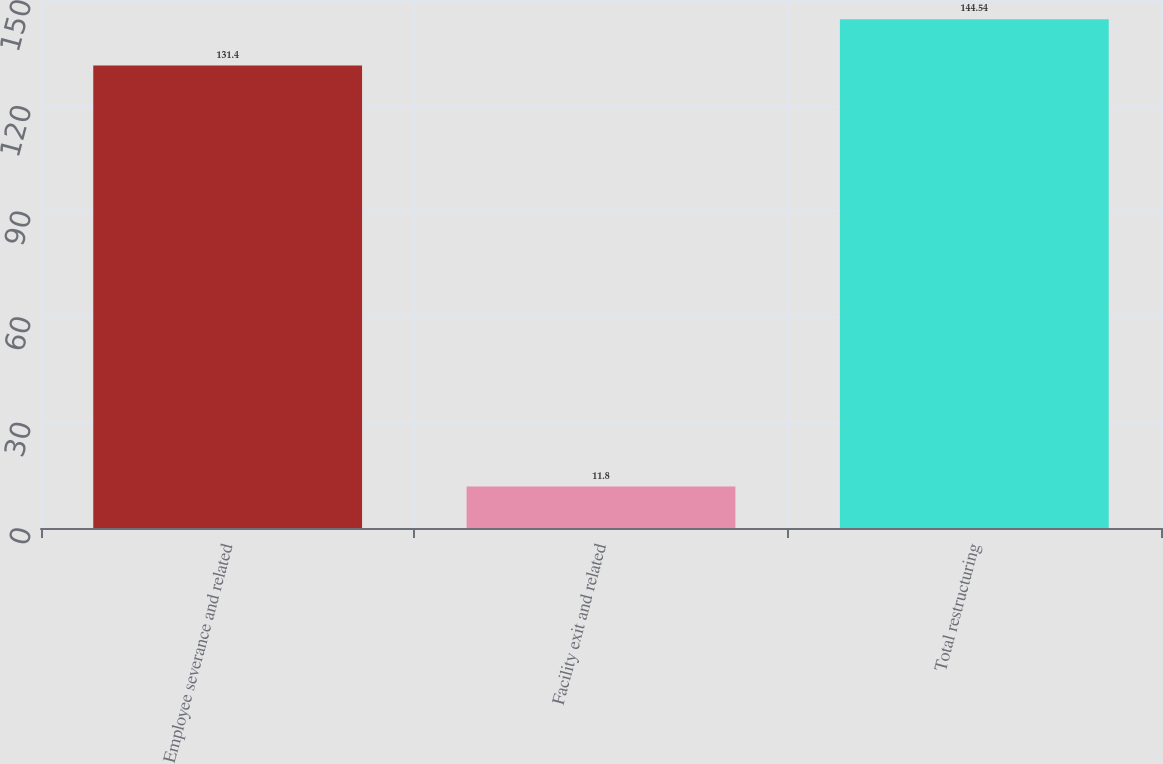Convert chart to OTSL. <chart><loc_0><loc_0><loc_500><loc_500><bar_chart><fcel>Employee severance and related<fcel>Facility exit and related<fcel>Total restructuring<nl><fcel>131.4<fcel>11.8<fcel>144.54<nl></chart> 